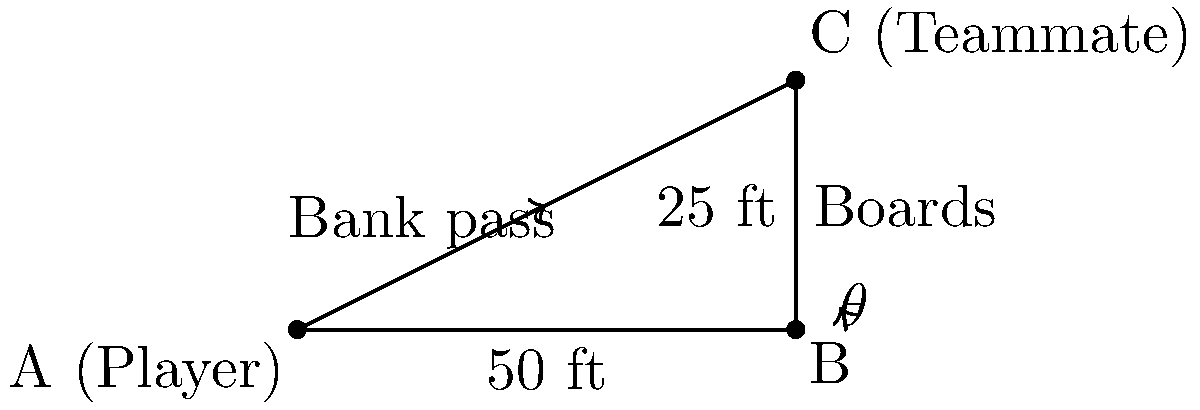As a defenseman, you're planning a bank pass off the boards to your teammate. The distance along the boards to the point where you want the puck to bounce is 50 feet, and your teammate is positioned 25 feet away from the boards at that point. What is the optimal angle $\theta$ (in degrees) at which you should send the puck for it to reach your teammate after bouncing off the boards, assuming perfect reflection? Let's approach this step-by-step:

1) We can treat this scenario as a right triangle, where:
   - The base is the distance along the boards (50 feet)
   - The height is the distance from the boards to the teammate (25 feet)
   - The hypotenuse is the path of the puck after bouncing off the boards

2) We need to find the angle $\theta$ that the puck should make with the boards.

3) In a right triangle, $\tan \theta = \frac{\text{opposite}}{\text{adjacent}}$

4) In this case:
   $\tan \theta = \frac{25}{50} = \frac{1}{2}$

5) To find $\theta$, we need to take the inverse tangent (arctangent):
   $\theta = \arctan(\frac{1}{2})$

6) Using a calculator or trigonometric tables:
   $\theta \approx 26.57°$

7) This angle ensures that the puck will bounce off the boards at the same angle, creating a perfect bank pass to the teammate.

8) Note: In real gameplay, you might adjust this slightly due to factors like puck spin, board irregularities, and player movement.
Answer: $26.57°$ 